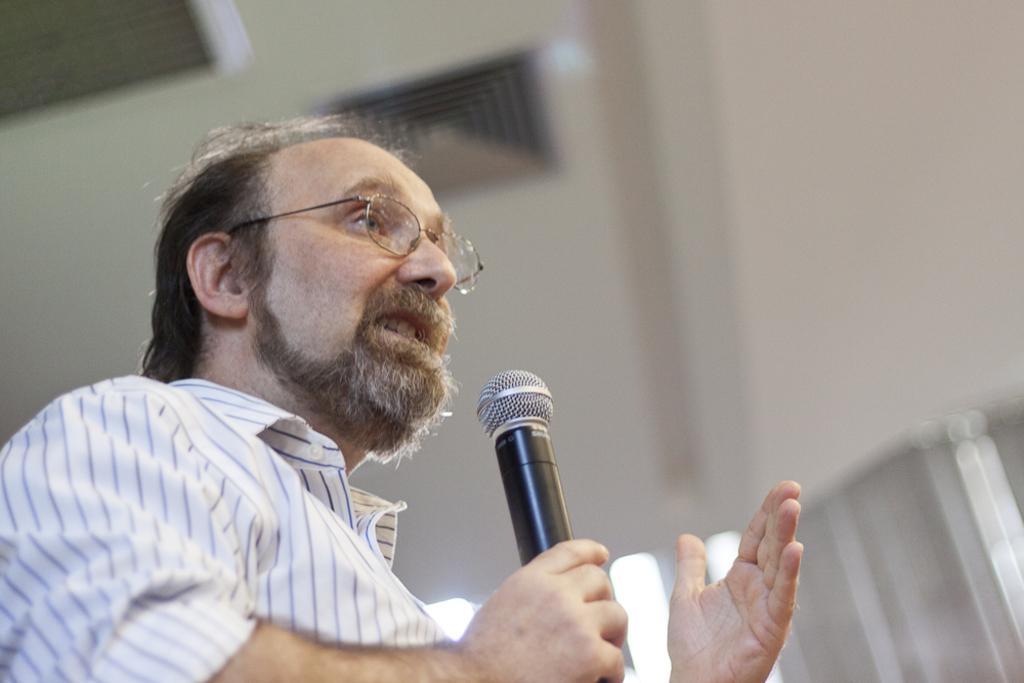Can you describe this image briefly? In this image we can see a person holding a mic. At the top of the image there is ceiling. 